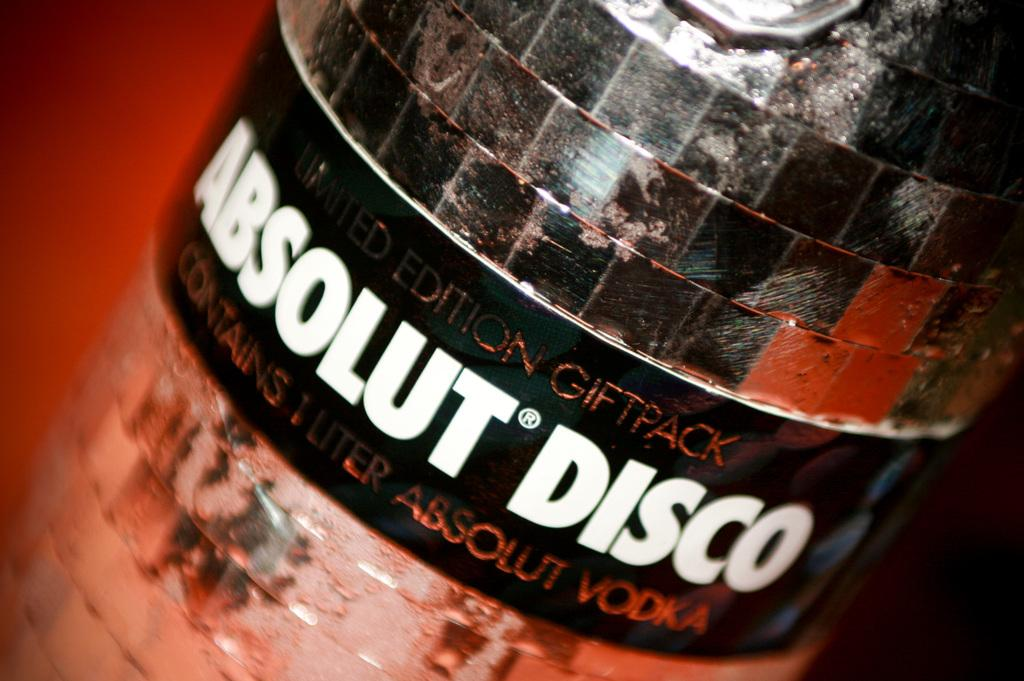Provide a one-sentence caption for the provided image. a bottle of liquor called absolut disco which is vodka. 